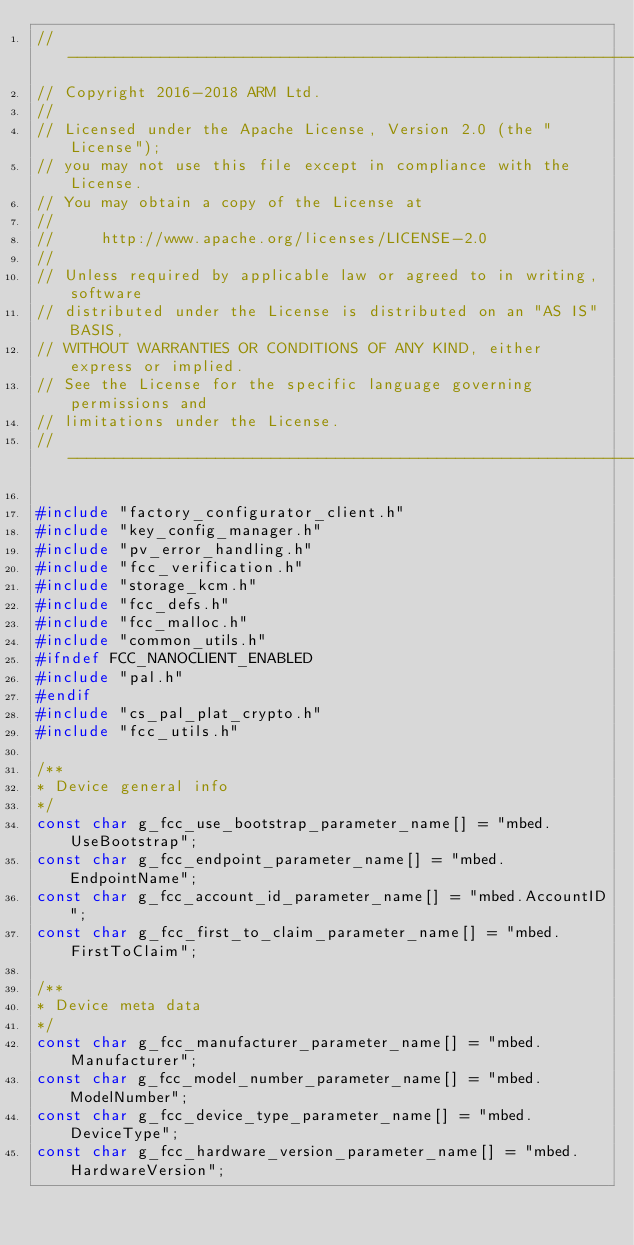<code> <loc_0><loc_0><loc_500><loc_500><_C_>// ----------------------------------------------------------------------------
// Copyright 2016-2018 ARM Ltd.
//
// Licensed under the Apache License, Version 2.0 (the "License");
// you may not use this file except in compliance with the License.
// You may obtain a copy of the License at
//
//     http://www.apache.org/licenses/LICENSE-2.0
//
// Unless required by applicable law or agreed to in writing, software
// distributed under the License is distributed on an "AS IS" BASIS,
// WITHOUT WARRANTIES OR CONDITIONS OF ANY KIND, either express or implied.
// See the License for the specific language governing permissions and
// limitations under the License.
// ----------------------------------------------------------------------------

#include "factory_configurator_client.h"
#include "key_config_manager.h"
#include "pv_error_handling.h"
#include "fcc_verification.h"
#include "storage_kcm.h"
#include "fcc_defs.h"
#include "fcc_malloc.h"
#include "common_utils.h"
#ifndef FCC_NANOCLIENT_ENABLED
#include "pal.h"
#endif
#include "cs_pal_plat_crypto.h"
#include "fcc_utils.h"

/**
* Device general info
*/
const char g_fcc_use_bootstrap_parameter_name[] = "mbed.UseBootstrap";
const char g_fcc_endpoint_parameter_name[] = "mbed.EndpointName";
const char g_fcc_account_id_parameter_name[] = "mbed.AccountID";
const char g_fcc_first_to_claim_parameter_name[] = "mbed.FirstToClaim";

/**
* Device meta data
*/
const char g_fcc_manufacturer_parameter_name[] = "mbed.Manufacturer";
const char g_fcc_model_number_parameter_name[] = "mbed.ModelNumber";
const char g_fcc_device_type_parameter_name[] = "mbed.DeviceType";
const char g_fcc_hardware_version_parameter_name[] = "mbed.HardwareVersion";</code> 